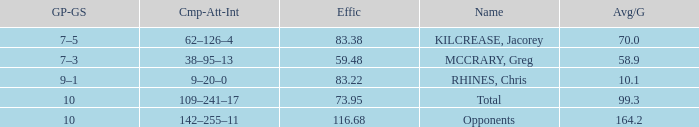What is the lowest effic with a 58.9 avg/g? 59.48. 